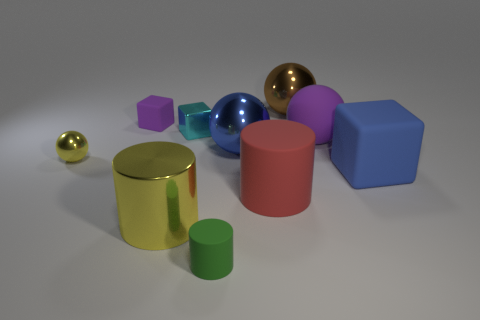There is a big red matte thing; is its shape the same as the large metallic object that is right of the large red thing?
Provide a short and direct response. No. Is there a small green rubber thing that has the same shape as the large brown shiny object?
Offer a very short reply. No. What shape is the yellow shiny object that is behind the big metallic object in front of the blue block?
Your answer should be very brief. Sphere. What shape is the purple matte thing that is to the right of the big yellow thing?
Offer a terse response. Sphere. There is a large shiny sphere that is in front of the brown sphere; is it the same color as the rubber block to the right of the metallic cube?
Make the answer very short. Yes. What number of objects are both behind the small cyan metal object and right of the big blue shiny thing?
Ensure brevity in your answer.  1. There is a cyan object that is made of the same material as the big brown object; what is its size?
Provide a succinct answer. Small. How big is the yellow metallic cylinder?
Offer a terse response. Large. What is the material of the large yellow cylinder?
Keep it short and to the point. Metal. Does the purple rubber object to the left of the red rubber thing have the same size as the brown ball?
Your response must be concise. No. 